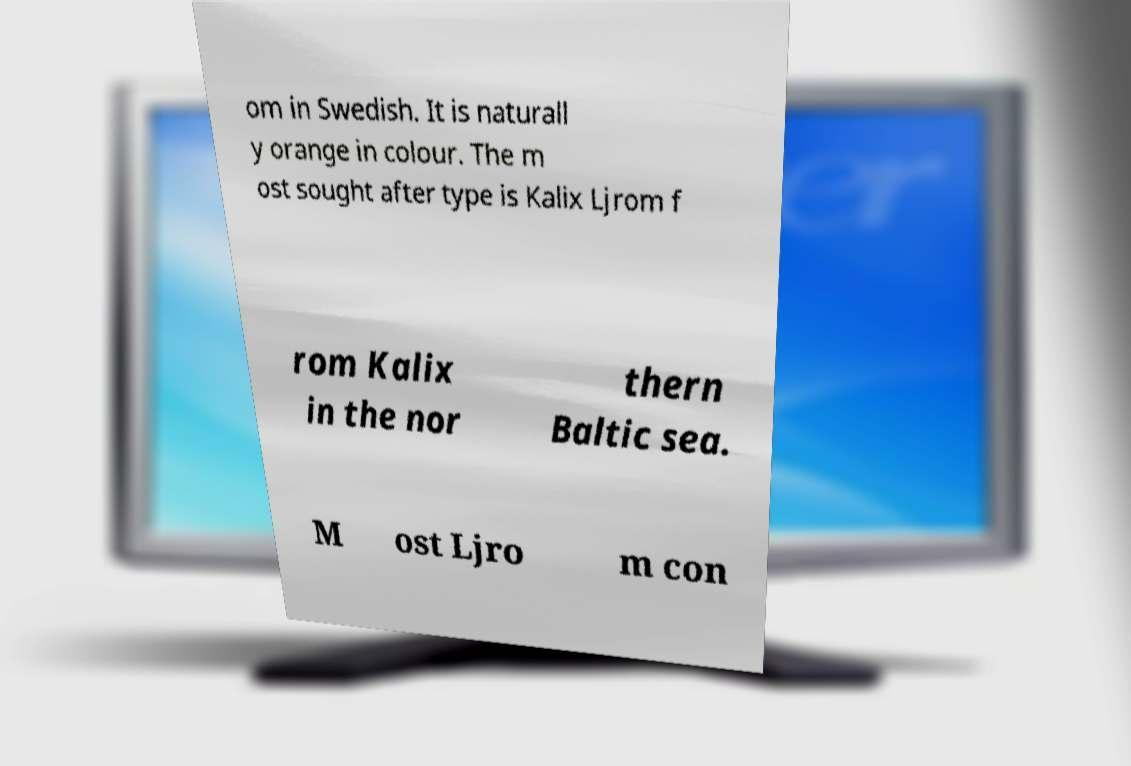There's text embedded in this image that I need extracted. Can you transcribe it verbatim? om in Swedish. It is naturall y orange in colour. The m ost sought after type is Kalix Ljrom f rom Kalix in the nor thern Baltic sea. M ost Ljro m con 